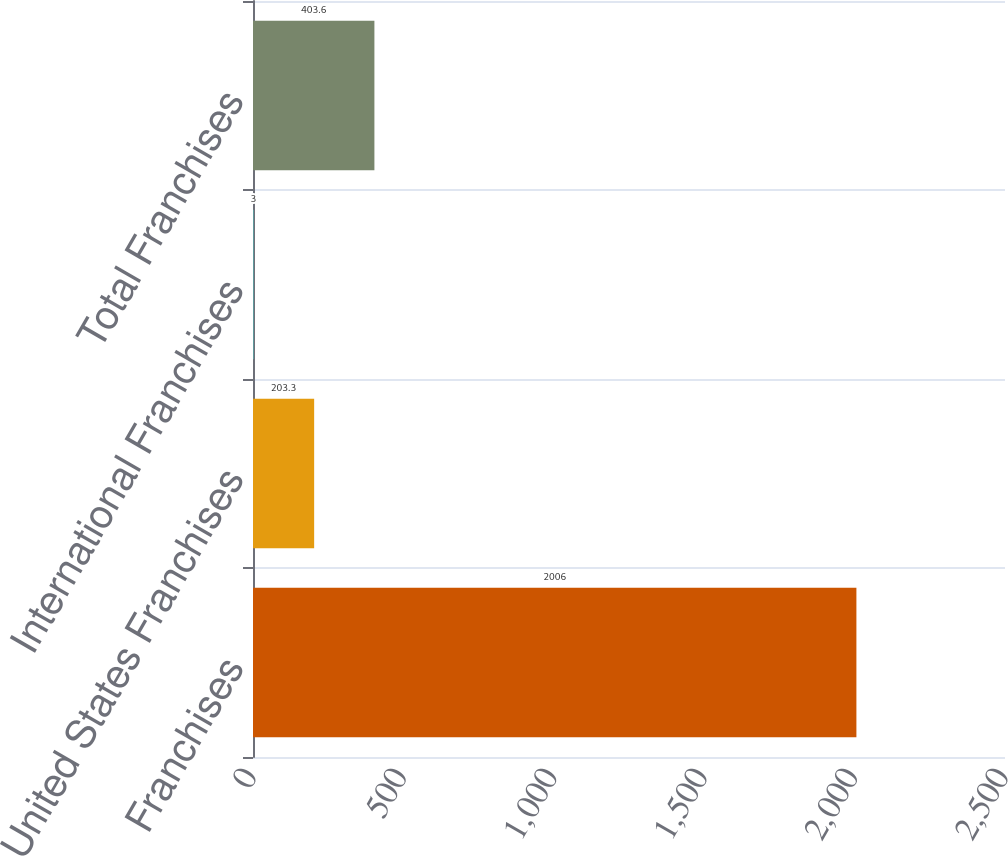Convert chart. <chart><loc_0><loc_0><loc_500><loc_500><bar_chart><fcel>Franchises<fcel>United States Franchises<fcel>International Franchises<fcel>Total Franchises<nl><fcel>2006<fcel>203.3<fcel>3<fcel>403.6<nl></chart> 